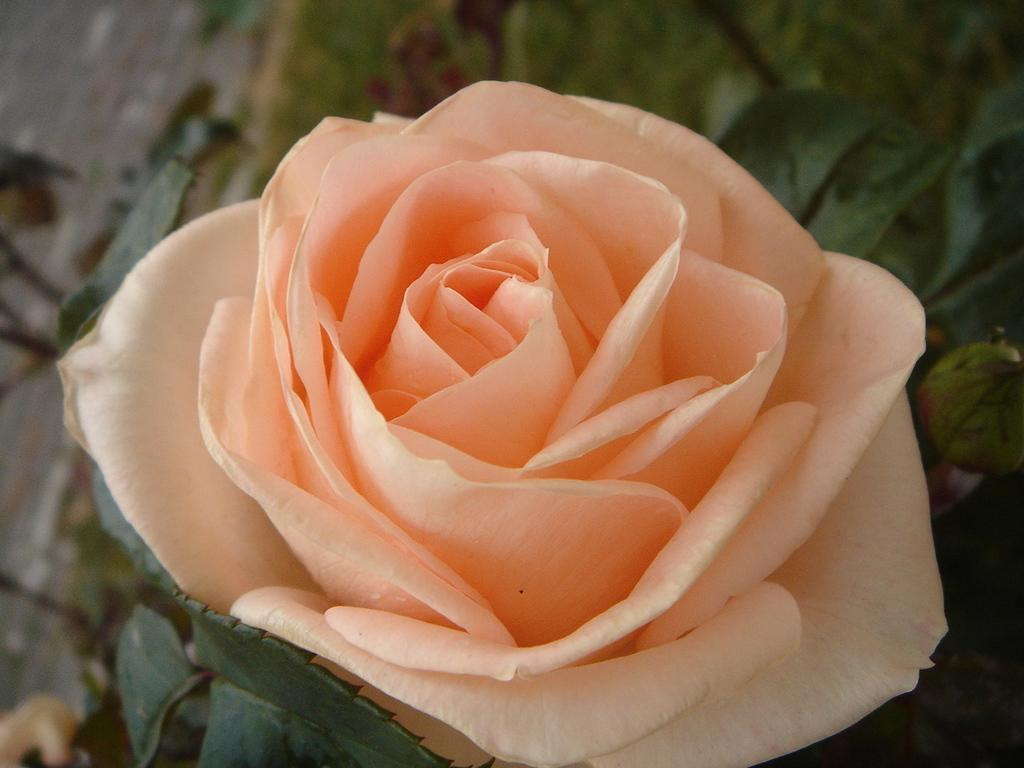What type of flower is in the image? There is a rose in the image. What color is the rose? The rose is light orange in color. What type of music does the uncle play in the image? There is no uncle or music present in the image; it only features a light orange rose. 